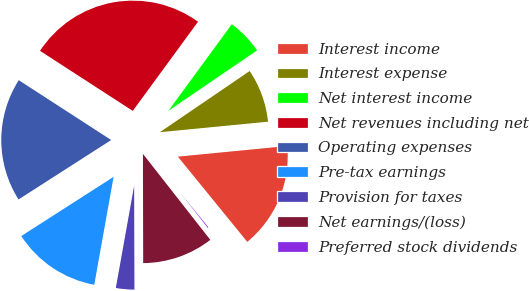Convert chart. <chart><loc_0><loc_0><loc_500><loc_500><pie_chart><fcel>Interest income<fcel>Interest expense<fcel>Net interest income<fcel>Net revenues including net<fcel>Operating expenses<fcel>Pre-tax earnings<fcel>Provision for taxes<fcel>Net earnings/(loss)<fcel>Preferred stock dividends<nl><fcel>15.66%<fcel>7.98%<fcel>5.42%<fcel>25.91%<fcel>18.22%<fcel>13.1%<fcel>2.86%<fcel>10.54%<fcel>0.3%<nl></chart> 